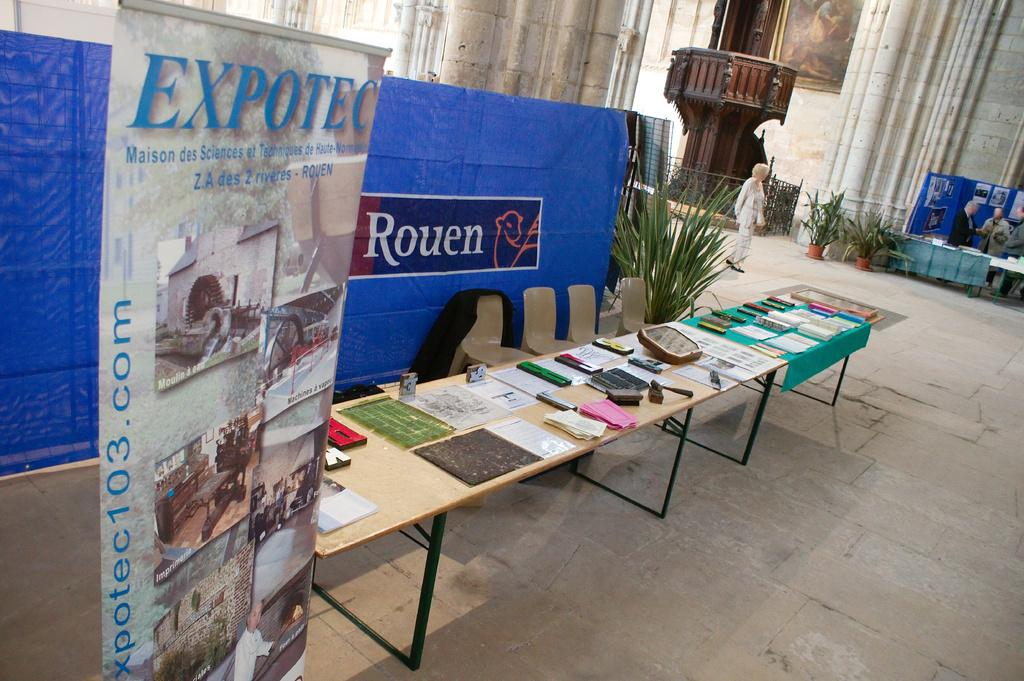What is on the table in the image? There are objects on the table in the image. What can be seen hanging or displayed in the image? There is a banner in the image. What type of vegetation is present in the image? There is a plant in the image. How many people are in the image? There is a group of people standing in the image. How many flies can be seen on the banner in the image? There are no flies present in the image. What sense is being used by the plant in the image? Plants do not have senses like humans or animals; they absorb nutrients and water through their roots. 